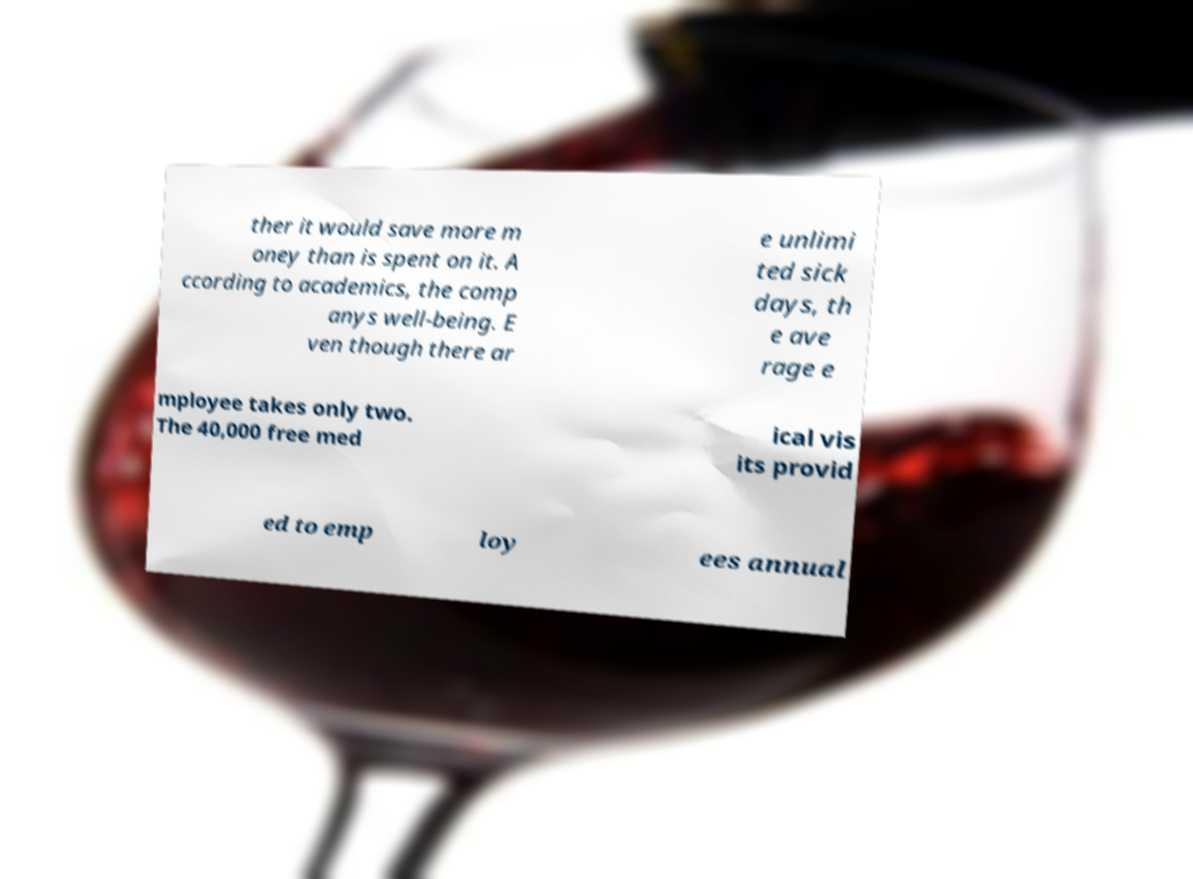Please read and relay the text visible in this image. What does it say? ther it would save more m oney than is spent on it. A ccording to academics, the comp anys well-being. E ven though there ar e unlimi ted sick days, th e ave rage e mployee takes only two. The 40,000 free med ical vis its provid ed to emp loy ees annual 